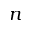<formula> <loc_0><loc_0><loc_500><loc_500>n</formula> 